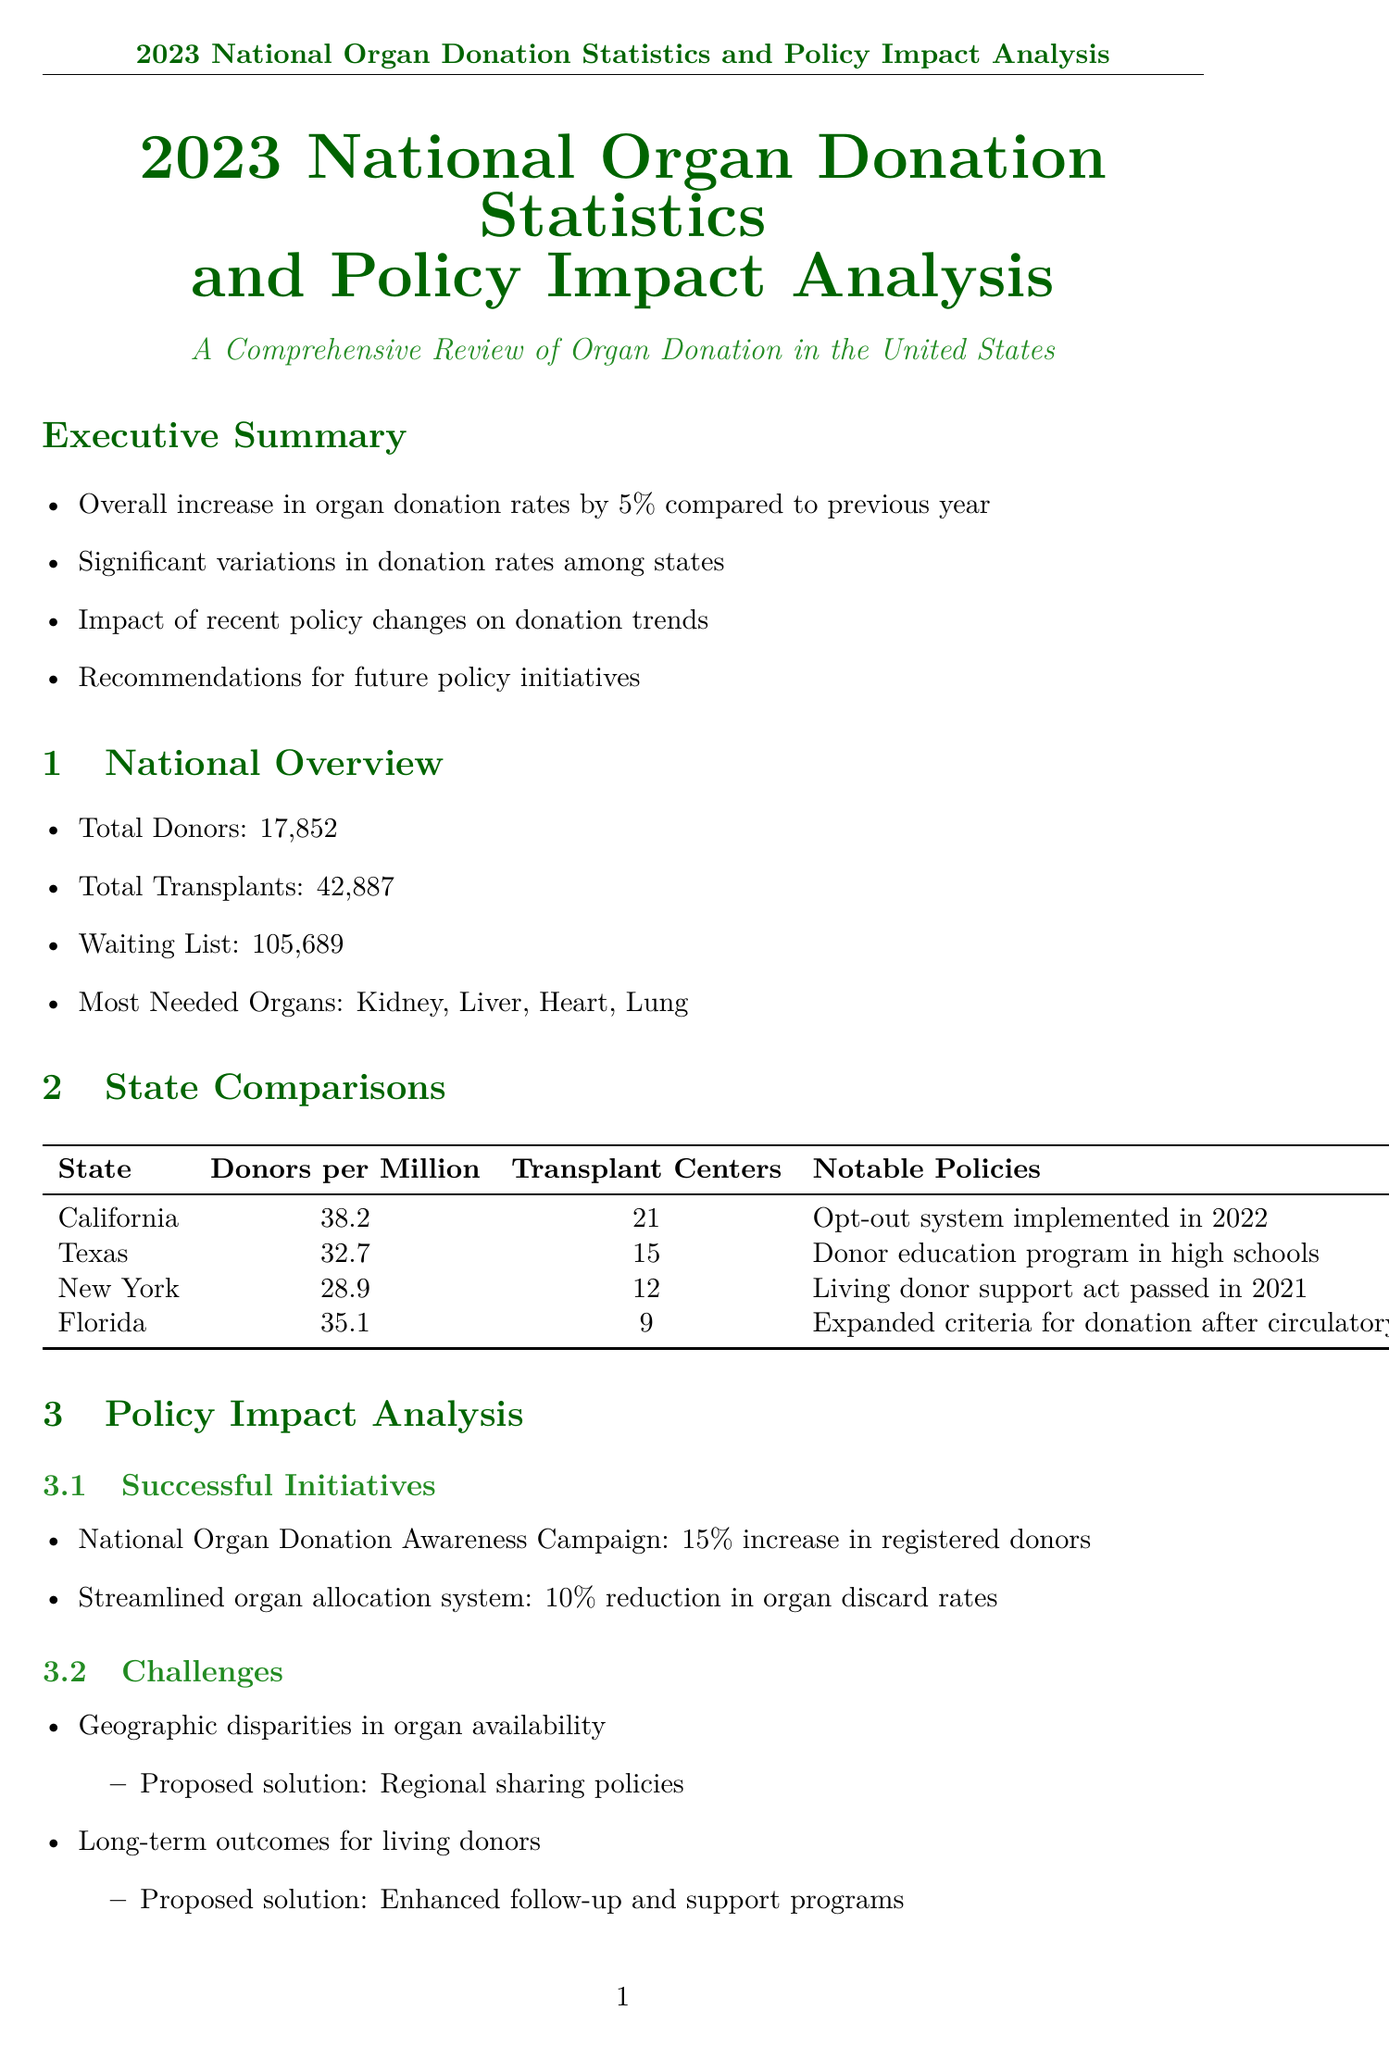What was the overall increase in organ donation rates? The overall increase in organ donation rates reported in the document is 5% compared to the previous year.
Answer: 5% How many total transplants were performed? The total number of transplants according to the national overview is 42,887.
Answer: 42887 Which state has the highest number of donors per million? California has the highest number of donors per million, with 38.2 donors per million.
Answer: 38.2 What notable policy was implemented in California? California implemented an opt-out system in 2022.
Answer: Opt-out system implemented in 2022 What is one challenge mentioned in the policy impact analysis? One challenge discussed is geographic disparities in organ availability.
Answer: Geographic disparities in organ availability Which organization's campaign resulted in a 15% increase in registered donors? The National Organ Donation Awareness Campaign resulted in a 15% increase in registered donors.
Answer: National Organ Donation Awareness Campaign How many collaborating organizations are listed? There are four collaborating organizations listed in the document.
Answer: 4 What is one future recommendation mentioned in the report? One future recommendation is to implement a nationwide opt-out system.
Answer: Implement nationwide opt-out system What percentage increase did Wisconsin achieve in new registrations? Wisconsin's donor registry optimization resulted in a 40% increase in new registrations.
Answer: 40% 